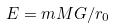Convert formula to latex. <formula><loc_0><loc_0><loc_500><loc_500>E = m M G / r _ { 0 }</formula> 